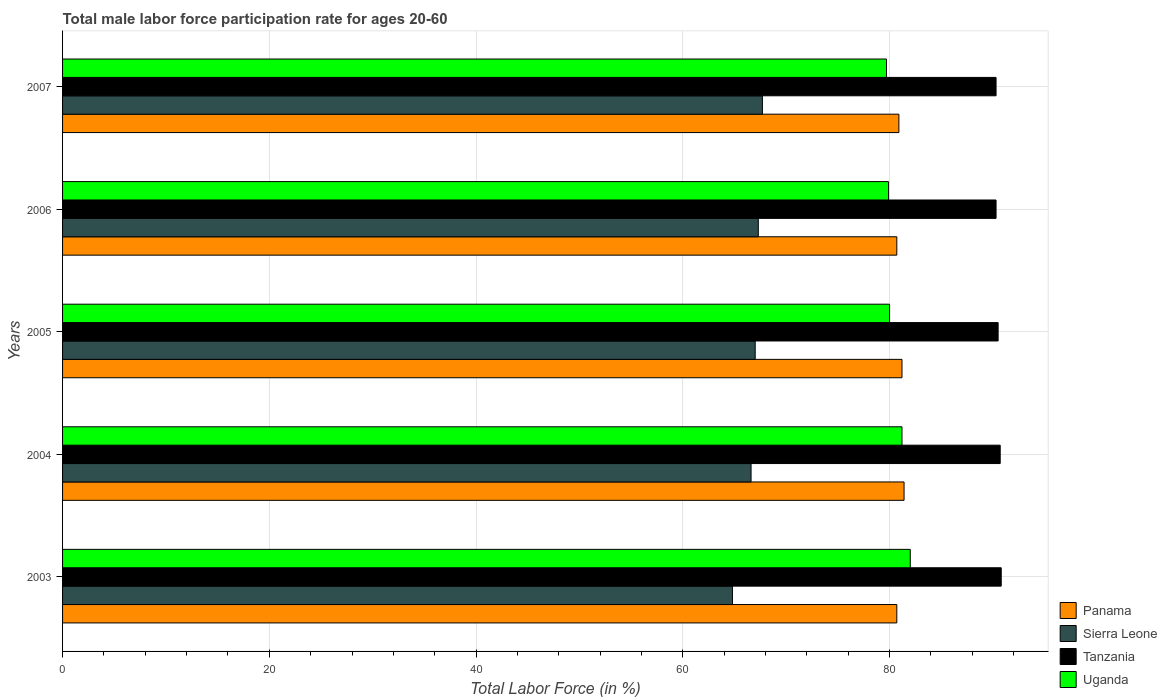How many groups of bars are there?
Your response must be concise. 5. Are the number of bars per tick equal to the number of legend labels?
Provide a succinct answer. Yes. How many bars are there on the 5th tick from the top?
Make the answer very short. 4. What is the label of the 2nd group of bars from the top?
Give a very brief answer. 2006. What is the male labor force participation rate in Panama in 2005?
Offer a very short reply. 81.2. Across all years, what is the maximum male labor force participation rate in Panama?
Ensure brevity in your answer.  81.4. Across all years, what is the minimum male labor force participation rate in Uganda?
Your answer should be compact. 79.7. In which year was the male labor force participation rate in Uganda maximum?
Offer a very short reply. 2003. What is the total male labor force participation rate in Uganda in the graph?
Provide a short and direct response. 402.8. What is the difference between the male labor force participation rate in Tanzania in 2004 and that in 2007?
Give a very brief answer. 0.4. What is the difference between the male labor force participation rate in Sierra Leone in 2004 and the male labor force participation rate in Panama in 2007?
Keep it short and to the point. -14.3. What is the average male labor force participation rate in Uganda per year?
Your response must be concise. 80.56. In the year 2006, what is the difference between the male labor force participation rate in Sierra Leone and male labor force participation rate in Uganda?
Provide a short and direct response. -12.6. In how many years, is the male labor force participation rate in Tanzania greater than 76 %?
Your answer should be compact. 5. What is the ratio of the male labor force participation rate in Panama in 2003 to that in 2007?
Your response must be concise. 1. Is the male labor force participation rate in Tanzania in 2005 less than that in 2007?
Offer a very short reply. No. Is the difference between the male labor force participation rate in Sierra Leone in 2003 and 2007 greater than the difference between the male labor force participation rate in Uganda in 2003 and 2007?
Provide a short and direct response. No. What is the difference between the highest and the second highest male labor force participation rate in Sierra Leone?
Ensure brevity in your answer.  0.4. What is the difference between the highest and the lowest male labor force participation rate in Uganda?
Keep it short and to the point. 2.3. In how many years, is the male labor force participation rate in Tanzania greater than the average male labor force participation rate in Tanzania taken over all years?
Provide a short and direct response. 2. Is the sum of the male labor force participation rate in Tanzania in 2006 and 2007 greater than the maximum male labor force participation rate in Sierra Leone across all years?
Make the answer very short. Yes. Is it the case that in every year, the sum of the male labor force participation rate in Panama and male labor force participation rate in Sierra Leone is greater than the sum of male labor force participation rate in Uganda and male labor force participation rate in Tanzania?
Make the answer very short. No. What does the 3rd bar from the top in 2003 represents?
Make the answer very short. Sierra Leone. What does the 3rd bar from the bottom in 2004 represents?
Your answer should be very brief. Tanzania. How many years are there in the graph?
Your answer should be very brief. 5. What is the difference between two consecutive major ticks on the X-axis?
Provide a short and direct response. 20. Does the graph contain grids?
Provide a short and direct response. Yes. How many legend labels are there?
Offer a very short reply. 4. How are the legend labels stacked?
Keep it short and to the point. Vertical. What is the title of the graph?
Offer a very short reply. Total male labor force participation rate for ages 20-60. What is the Total Labor Force (in %) in Panama in 2003?
Your answer should be compact. 80.7. What is the Total Labor Force (in %) of Sierra Leone in 2003?
Offer a terse response. 64.8. What is the Total Labor Force (in %) in Tanzania in 2003?
Ensure brevity in your answer.  90.8. What is the Total Labor Force (in %) of Uganda in 2003?
Offer a terse response. 82. What is the Total Labor Force (in %) of Panama in 2004?
Your answer should be very brief. 81.4. What is the Total Labor Force (in %) of Sierra Leone in 2004?
Offer a very short reply. 66.6. What is the Total Labor Force (in %) of Tanzania in 2004?
Offer a very short reply. 90.7. What is the Total Labor Force (in %) of Uganda in 2004?
Make the answer very short. 81.2. What is the Total Labor Force (in %) in Panama in 2005?
Your answer should be compact. 81.2. What is the Total Labor Force (in %) in Sierra Leone in 2005?
Provide a short and direct response. 67. What is the Total Labor Force (in %) of Tanzania in 2005?
Provide a succinct answer. 90.5. What is the Total Labor Force (in %) of Uganda in 2005?
Your answer should be very brief. 80. What is the Total Labor Force (in %) of Panama in 2006?
Offer a terse response. 80.7. What is the Total Labor Force (in %) of Sierra Leone in 2006?
Your answer should be compact. 67.3. What is the Total Labor Force (in %) of Tanzania in 2006?
Your response must be concise. 90.3. What is the Total Labor Force (in %) of Uganda in 2006?
Make the answer very short. 79.9. What is the Total Labor Force (in %) in Panama in 2007?
Your answer should be very brief. 80.9. What is the Total Labor Force (in %) in Sierra Leone in 2007?
Make the answer very short. 67.7. What is the Total Labor Force (in %) of Tanzania in 2007?
Provide a succinct answer. 90.3. What is the Total Labor Force (in %) in Uganda in 2007?
Make the answer very short. 79.7. Across all years, what is the maximum Total Labor Force (in %) in Panama?
Offer a terse response. 81.4. Across all years, what is the maximum Total Labor Force (in %) in Sierra Leone?
Your response must be concise. 67.7. Across all years, what is the maximum Total Labor Force (in %) of Tanzania?
Offer a terse response. 90.8. Across all years, what is the minimum Total Labor Force (in %) in Panama?
Provide a succinct answer. 80.7. Across all years, what is the minimum Total Labor Force (in %) in Sierra Leone?
Make the answer very short. 64.8. Across all years, what is the minimum Total Labor Force (in %) of Tanzania?
Give a very brief answer. 90.3. Across all years, what is the minimum Total Labor Force (in %) of Uganda?
Your response must be concise. 79.7. What is the total Total Labor Force (in %) of Panama in the graph?
Keep it short and to the point. 404.9. What is the total Total Labor Force (in %) of Sierra Leone in the graph?
Keep it short and to the point. 333.4. What is the total Total Labor Force (in %) in Tanzania in the graph?
Your answer should be very brief. 452.6. What is the total Total Labor Force (in %) in Uganda in the graph?
Provide a succinct answer. 402.8. What is the difference between the Total Labor Force (in %) in Panama in 2003 and that in 2004?
Ensure brevity in your answer.  -0.7. What is the difference between the Total Labor Force (in %) of Sierra Leone in 2003 and that in 2004?
Your answer should be compact. -1.8. What is the difference between the Total Labor Force (in %) in Panama in 2003 and that in 2005?
Keep it short and to the point. -0.5. What is the difference between the Total Labor Force (in %) of Sierra Leone in 2003 and that in 2005?
Your answer should be compact. -2.2. What is the difference between the Total Labor Force (in %) of Uganda in 2003 and that in 2005?
Your response must be concise. 2. What is the difference between the Total Labor Force (in %) in Panama in 2003 and that in 2006?
Your response must be concise. 0. What is the difference between the Total Labor Force (in %) of Sierra Leone in 2003 and that in 2006?
Keep it short and to the point. -2.5. What is the difference between the Total Labor Force (in %) in Panama in 2003 and that in 2007?
Offer a very short reply. -0.2. What is the difference between the Total Labor Force (in %) in Panama in 2004 and that in 2005?
Offer a very short reply. 0.2. What is the difference between the Total Labor Force (in %) in Panama in 2004 and that in 2006?
Your answer should be very brief. 0.7. What is the difference between the Total Labor Force (in %) of Panama in 2004 and that in 2007?
Offer a very short reply. 0.5. What is the difference between the Total Labor Force (in %) in Sierra Leone in 2004 and that in 2007?
Give a very brief answer. -1.1. What is the difference between the Total Labor Force (in %) in Panama in 2005 and that in 2006?
Offer a very short reply. 0.5. What is the difference between the Total Labor Force (in %) in Panama in 2005 and that in 2007?
Your answer should be compact. 0.3. What is the difference between the Total Labor Force (in %) in Sierra Leone in 2005 and that in 2007?
Offer a terse response. -0.7. What is the difference between the Total Labor Force (in %) in Panama in 2006 and that in 2007?
Your response must be concise. -0.2. What is the difference between the Total Labor Force (in %) in Sierra Leone in 2006 and that in 2007?
Offer a terse response. -0.4. What is the difference between the Total Labor Force (in %) of Uganda in 2006 and that in 2007?
Your response must be concise. 0.2. What is the difference between the Total Labor Force (in %) of Panama in 2003 and the Total Labor Force (in %) of Tanzania in 2004?
Your answer should be compact. -10. What is the difference between the Total Labor Force (in %) in Sierra Leone in 2003 and the Total Labor Force (in %) in Tanzania in 2004?
Your answer should be compact. -25.9. What is the difference between the Total Labor Force (in %) in Sierra Leone in 2003 and the Total Labor Force (in %) in Uganda in 2004?
Make the answer very short. -16.4. What is the difference between the Total Labor Force (in %) of Panama in 2003 and the Total Labor Force (in %) of Sierra Leone in 2005?
Offer a terse response. 13.7. What is the difference between the Total Labor Force (in %) in Panama in 2003 and the Total Labor Force (in %) in Tanzania in 2005?
Your answer should be compact. -9.8. What is the difference between the Total Labor Force (in %) of Sierra Leone in 2003 and the Total Labor Force (in %) of Tanzania in 2005?
Offer a very short reply. -25.7. What is the difference between the Total Labor Force (in %) of Sierra Leone in 2003 and the Total Labor Force (in %) of Uganda in 2005?
Your answer should be very brief. -15.2. What is the difference between the Total Labor Force (in %) in Panama in 2003 and the Total Labor Force (in %) in Sierra Leone in 2006?
Your answer should be compact. 13.4. What is the difference between the Total Labor Force (in %) of Panama in 2003 and the Total Labor Force (in %) of Tanzania in 2006?
Your response must be concise. -9.6. What is the difference between the Total Labor Force (in %) of Sierra Leone in 2003 and the Total Labor Force (in %) of Tanzania in 2006?
Ensure brevity in your answer.  -25.5. What is the difference between the Total Labor Force (in %) in Sierra Leone in 2003 and the Total Labor Force (in %) in Uganda in 2006?
Ensure brevity in your answer.  -15.1. What is the difference between the Total Labor Force (in %) in Tanzania in 2003 and the Total Labor Force (in %) in Uganda in 2006?
Provide a short and direct response. 10.9. What is the difference between the Total Labor Force (in %) in Panama in 2003 and the Total Labor Force (in %) in Tanzania in 2007?
Give a very brief answer. -9.6. What is the difference between the Total Labor Force (in %) in Panama in 2003 and the Total Labor Force (in %) in Uganda in 2007?
Offer a very short reply. 1. What is the difference between the Total Labor Force (in %) of Sierra Leone in 2003 and the Total Labor Force (in %) of Tanzania in 2007?
Provide a succinct answer. -25.5. What is the difference between the Total Labor Force (in %) of Sierra Leone in 2003 and the Total Labor Force (in %) of Uganda in 2007?
Your answer should be very brief. -14.9. What is the difference between the Total Labor Force (in %) in Panama in 2004 and the Total Labor Force (in %) in Sierra Leone in 2005?
Your answer should be compact. 14.4. What is the difference between the Total Labor Force (in %) of Panama in 2004 and the Total Labor Force (in %) of Uganda in 2005?
Your answer should be very brief. 1.4. What is the difference between the Total Labor Force (in %) of Sierra Leone in 2004 and the Total Labor Force (in %) of Tanzania in 2005?
Your answer should be compact. -23.9. What is the difference between the Total Labor Force (in %) in Sierra Leone in 2004 and the Total Labor Force (in %) in Uganda in 2005?
Your response must be concise. -13.4. What is the difference between the Total Labor Force (in %) of Tanzania in 2004 and the Total Labor Force (in %) of Uganda in 2005?
Offer a very short reply. 10.7. What is the difference between the Total Labor Force (in %) in Panama in 2004 and the Total Labor Force (in %) in Tanzania in 2006?
Offer a terse response. -8.9. What is the difference between the Total Labor Force (in %) of Panama in 2004 and the Total Labor Force (in %) of Uganda in 2006?
Keep it short and to the point. 1.5. What is the difference between the Total Labor Force (in %) of Sierra Leone in 2004 and the Total Labor Force (in %) of Tanzania in 2006?
Make the answer very short. -23.7. What is the difference between the Total Labor Force (in %) of Panama in 2004 and the Total Labor Force (in %) of Tanzania in 2007?
Your answer should be compact. -8.9. What is the difference between the Total Labor Force (in %) in Panama in 2004 and the Total Labor Force (in %) in Uganda in 2007?
Offer a very short reply. 1.7. What is the difference between the Total Labor Force (in %) of Sierra Leone in 2004 and the Total Labor Force (in %) of Tanzania in 2007?
Provide a succinct answer. -23.7. What is the difference between the Total Labor Force (in %) in Sierra Leone in 2004 and the Total Labor Force (in %) in Uganda in 2007?
Keep it short and to the point. -13.1. What is the difference between the Total Labor Force (in %) of Panama in 2005 and the Total Labor Force (in %) of Tanzania in 2006?
Provide a succinct answer. -9.1. What is the difference between the Total Labor Force (in %) of Sierra Leone in 2005 and the Total Labor Force (in %) of Tanzania in 2006?
Provide a succinct answer. -23.3. What is the difference between the Total Labor Force (in %) in Tanzania in 2005 and the Total Labor Force (in %) in Uganda in 2006?
Keep it short and to the point. 10.6. What is the difference between the Total Labor Force (in %) in Panama in 2005 and the Total Labor Force (in %) in Tanzania in 2007?
Your answer should be very brief. -9.1. What is the difference between the Total Labor Force (in %) of Panama in 2005 and the Total Labor Force (in %) of Uganda in 2007?
Keep it short and to the point. 1.5. What is the difference between the Total Labor Force (in %) of Sierra Leone in 2005 and the Total Labor Force (in %) of Tanzania in 2007?
Ensure brevity in your answer.  -23.3. What is the difference between the Total Labor Force (in %) in Sierra Leone in 2005 and the Total Labor Force (in %) in Uganda in 2007?
Make the answer very short. -12.7. What is the difference between the Total Labor Force (in %) of Panama in 2006 and the Total Labor Force (in %) of Uganda in 2007?
Provide a short and direct response. 1. What is the difference between the Total Labor Force (in %) in Sierra Leone in 2006 and the Total Labor Force (in %) in Tanzania in 2007?
Give a very brief answer. -23. What is the difference between the Total Labor Force (in %) in Sierra Leone in 2006 and the Total Labor Force (in %) in Uganda in 2007?
Your answer should be compact. -12.4. What is the average Total Labor Force (in %) in Panama per year?
Make the answer very short. 80.98. What is the average Total Labor Force (in %) in Sierra Leone per year?
Ensure brevity in your answer.  66.68. What is the average Total Labor Force (in %) in Tanzania per year?
Keep it short and to the point. 90.52. What is the average Total Labor Force (in %) in Uganda per year?
Keep it short and to the point. 80.56. In the year 2003, what is the difference between the Total Labor Force (in %) of Panama and Total Labor Force (in %) of Tanzania?
Offer a very short reply. -10.1. In the year 2003, what is the difference between the Total Labor Force (in %) of Panama and Total Labor Force (in %) of Uganda?
Provide a succinct answer. -1.3. In the year 2003, what is the difference between the Total Labor Force (in %) of Sierra Leone and Total Labor Force (in %) of Tanzania?
Your response must be concise. -26. In the year 2003, what is the difference between the Total Labor Force (in %) of Sierra Leone and Total Labor Force (in %) of Uganda?
Your response must be concise. -17.2. In the year 2004, what is the difference between the Total Labor Force (in %) of Panama and Total Labor Force (in %) of Sierra Leone?
Offer a very short reply. 14.8. In the year 2004, what is the difference between the Total Labor Force (in %) of Panama and Total Labor Force (in %) of Tanzania?
Provide a succinct answer. -9.3. In the year 2004, what is the difference between the Total Labor Force (in %) in Panama and Total Labor Force (in %) in Uganda?
Your answer should be very brief. 0.2. In the year 2004, what is the difference between the Total Labor Force (in %) of Sierra Leone and Total Labor Force (in %) of Tanzania?
Ensure brevity in your answer.  -24.1. In the year 2004, what is the difference between the Total Labor Force (in %) of Sierra Leone and Total Labor Force (in %) of Uganda?
Provide a succinct answer. -14.6. In the year 2004, what is the difference between the Total Labor Force (in %) of Tanzania and Total Labor Force (in %) of Uganda?
Your answer should be compact. 9.5. In the year 2005, what is the difference between the Total Labor Force (in %) in Panama and Total Labor Force (in %) in Tanzania?
Offer a very short reply. -9.3. In the year 2005, what is the difference between the Total Labor Force (in %) of Sierra Leone and Total Labor Force (in %) of Tanzania?
Provide a short and direct response. -23.5. In the year 2005, what is the difference between the Total Labor Force (in %) of Sierra Leone and Total Labor Force (in %) of Uganda?
Keep it short and to the point. -13. In the year 2006, what is the difference between the Total Labor Force (in %) in Panama and Total Labor Force (in %) in Sierra Leone?
Provide a short and direct response. 13.4. In the year 2006, what is the difference between the Total Labor Force (in %) in Panama and Total Labor Force (in %) in Uganda?
Make the answer very short. 0.8. In the year 2006, what is the difference between the Total Labor Force (in %) in Sierra Leone and Total Labor Force (in %) in Tanzania?
Your response must be concise. -23. In the year 2007, what is the difference between the Total Labor Force (in %) in Sierra Leone and Total Labor Force (in %) in Tanzania?
Your answer should be compact. -22.6. What is the ratio of the Total Labor Force (in %) of Panama in 2003 to that in 2004?
Give a very brief answer. 0.99. What is the ratio of the Total Labor Force (in %) in Tanzania in 2003 to that in 2004?
Ensure brevity in your answer.  1. What is the ratio of the Total Labor Force (in %) of Uganda in 2003 to that in 2004?
Your response must be concise. 1.01. What is the ratio of the Total Labor Force (in %) of Panama in 2003 to that in 2005?
Make the answer very short. 0.99. What is the ratio of the Total Labor Force (in %) of Sierra Leone in 2003 to that in 2005?
Offer a very short reply. 0.97. What is the ratio of the Total Labor Force (in %) of Uganda in 2003 to that in 2005?
Your answer should be compact. 1.02. What is the ratio of the Total Labor Force (in %) of Panama in 2003 to that in 2006?
Offer a terse response. 1. What is the ratio of the Total Labor Force (in %) of Sierra Leone in 2003 to that in 2006?
Ensure brevity in your answer.  0.96. What is the ratio of the Total Labor Force (in %) in Tanzania in 2003 to that in 2006?
Ensure brevity in your answer.  1.01. What is the ratio of the Total Labor Force (in %) of Uganda in 2003 to that in 2006?
Provide a succinct answer. 1.03. What is the ratio of the Total Labor Force (in %) in Sierra Leone in 2003 to that in 2007?
Keep it short and to the point. 0.96. What is the ratio of the Total Labor Force (in %) of Uganda in 2003 to that in 2007?
Your response must be concise. 1.03. What is the ratio of the Total Labor Force (in %) of Sierra Leone in 2004 to that in 2005?
Give a very brief answer. 0.99. What is the ratio of the Total Labor Force (in %) of Tanzania in 2004 to that in 2005?
Offer a terse response. 1. What is the ratio of the Total Labor Force (in %) in Panama in 2004 to that in 2006?
Provide a short and direct response. 1.01. What is the ratio of the Total Labor Force (in %) in Uganda in 2004 to that in 2006?
Provide a short and direct response. 1.02. What is the ratio of the Total Labor Force (in %) of Panama in 2004 to that in 2007?
Your answer should be very brief. 1.01. What is the ratio of the Total Labor Force (in %) of Sierra Leone in 2004 to that in 2007?
Provide a short and direct response. 0.98. What is the ratio of the Total Labor Force (in %) in Uganda in 2004 to that in 2007?
Make the answer very short. 1.02. What is the ratio of the Total Labor Force (in %) in Tanzania in 2005 to that in 2006?
Your answer should be very brief. 1. What is the ratio of the Total Labor Force (in %) in Uganda in 2005 to that in 2006?
Give a very brief answer. 1. What is the ratio of the Total Labor Force (in %) of Panama in 2005 to that in 2007?
Your answer should be compact. 1. What is the ratio of the Total Labor Force (in %) in Uganda in 2005 to that in 2007?
Make the answer very short. 1. What is the ratio of the Total Labor Force (in %) of Sierra Leone in 2006 to that in 2007?
Ensure brevity in your answer.  0.99. What is the difference between the highest and the second highest Total Labor Force (in %) of Panama?
Offer a terse response. 0.2. What is the difference between the highest and the second highest Total Labor Force (in %) in Uganda?
Offer a very short reply. 0.8. What is the difference between the highest and the lowest Total Labor Force (in %) in Tanzania?
Give a very brief answer. 0.5. What is the difference between the highest and the lowest Total Labor Force (in %) in Uganda?
Your answer should be compact. 2.3. 